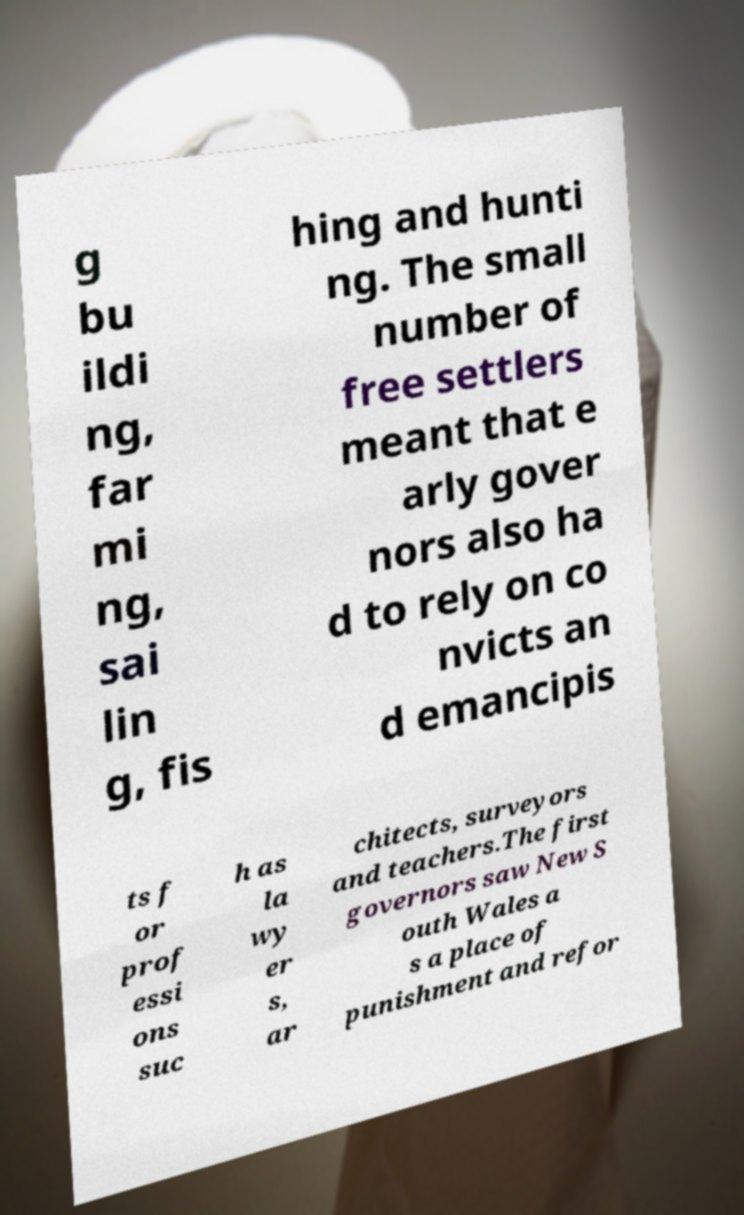Can you read and provide the text displayed in the image?This photo seems to have some interesting text. Can you extract and type it out for me? g bu ildi ng, far mi ng, sai lin g, fis hing and hunti ng. The small number of free settlers meant that e arly gover nors also ha d to rely on co nvicts an d emancipis ts f or prof essi ons suc h as la wy er s, ar chitects, surveyors and teachers.The first governors saw New S outh Wales a s a place of punishment and refor 